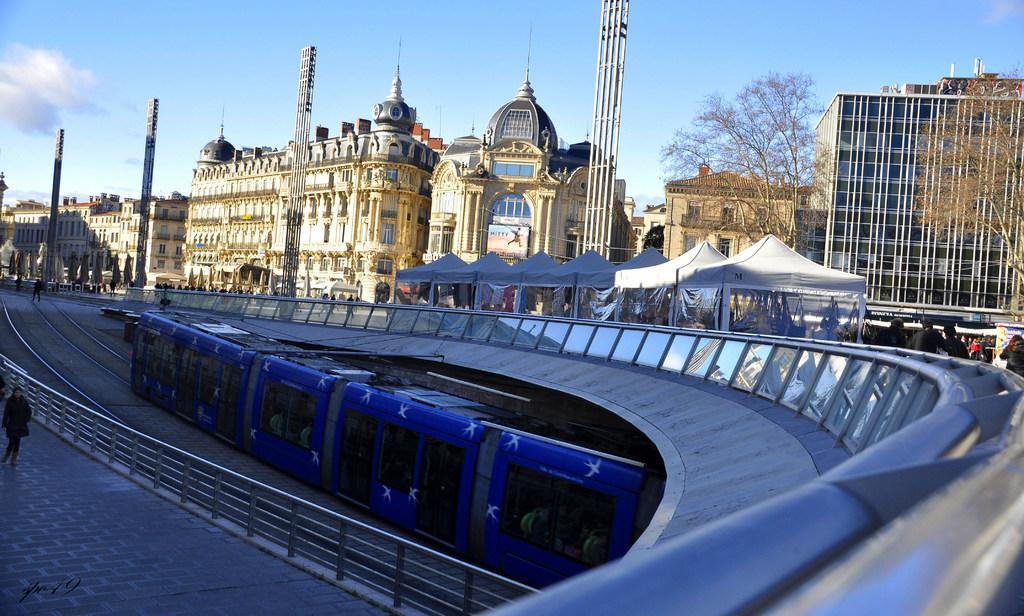How would you summarize this image in a sentence or two? In this image there is a train on a railway track in the bottom of this image. There are some buildings in the background. There are some trees on the right side of this image. There is a sky on the top of this image. There are some persons standing on the right side of this image and left side of this image as well. 